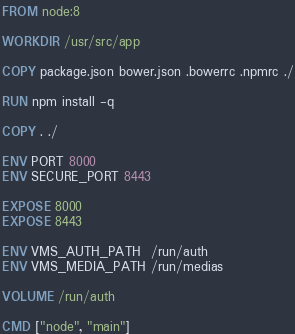Convert code to text. <code><loc_0><loc_0><loc_500><loc_500><_Dockerfile_>FROM node:8

WORKDIR /usr/src/app

COPY package.json bower.json .bowerrc .npmrc ./

RUN npm install -q

COPY . ./

ENV PORT 8000
ENV SECURE_PORT 8443

EXPOSE 8000
EXPOSE 8443

ENV VMS_AUTH_PATH  /run/auth
ENV VMS_MEDIA_PATH /run/medias

VOLUME /run/auth

CMD ["node", "main"]
</code> 